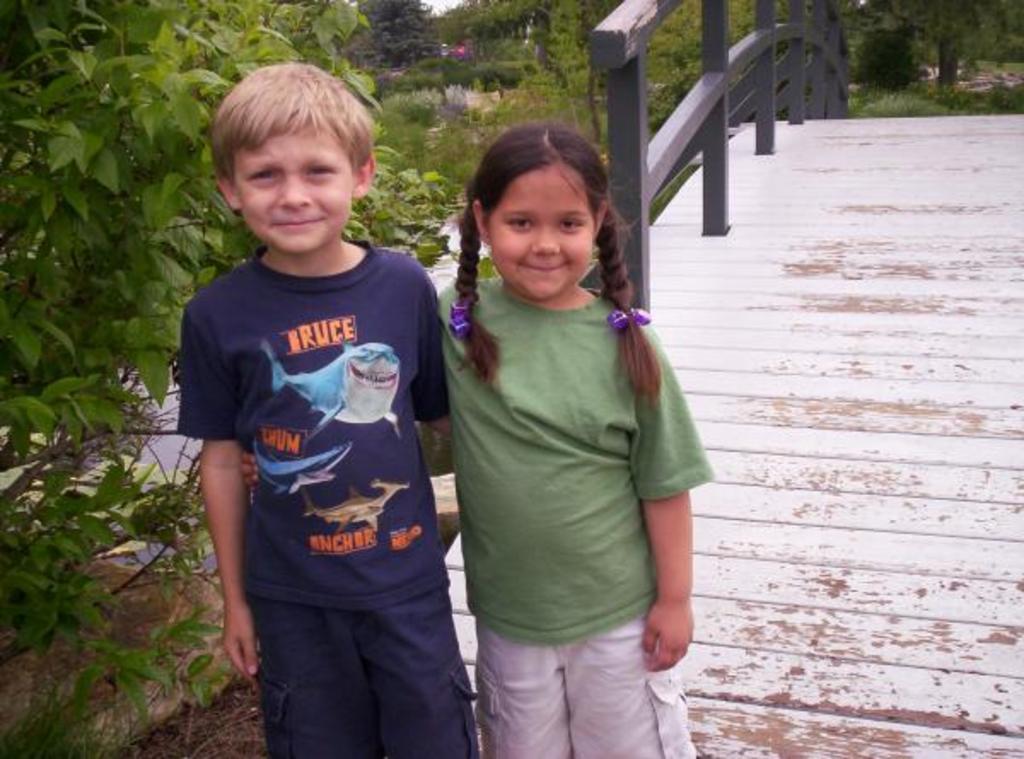Describe this image in one or two sentences. In this image, we can see two kids standing and we can see the wooden bridge, there are some green plants and trees. 